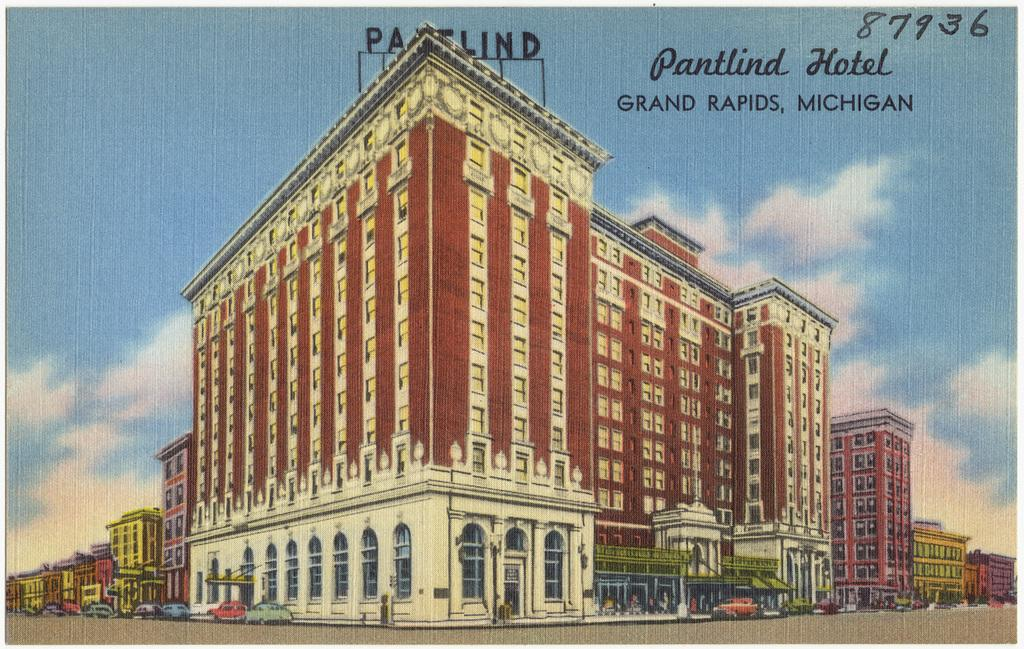What is the main structure in the picture? There is a building in the picture. What feature can be seen on the building? The building has windows. What can be seen on the left side of the picture? There are cars parked on the left side of the picture. What type of pathway is visible in the picture? There is a road in the picture. What sign is present in the image? There is a name board in the picture. How would you describe the weather based on the image? The sky is clear in the picture, suggesting good weather. Can you tell me how many tigers are walking on the road in the image? There are no tigers present in the image; it features a building, cars, a road, and a name board. What type of order is being followed by the cars in the image? There is no indication of any specific order being followed by the cars in the image. 